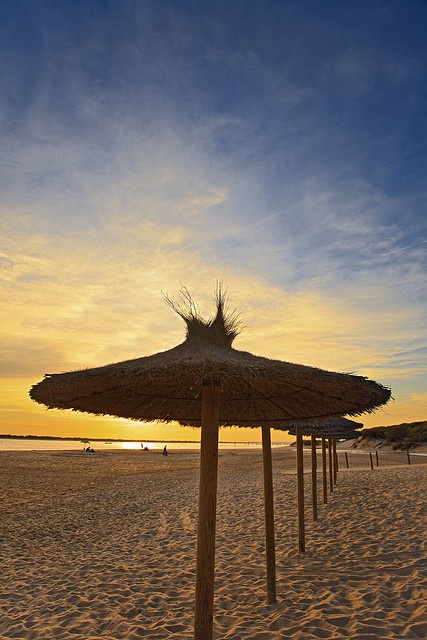Describe the objects in this image and their specific colors. I can see umbrella in darkblue, black, maroon, and khaki tones, umbrella in darkblue, black, olive, and gray tones, people in darkblue, black, maroon, navy, and tan tones, people in darkblue, black, maroon, and brown tones, and people in darkblue, black, navy, and red tones in this image. 